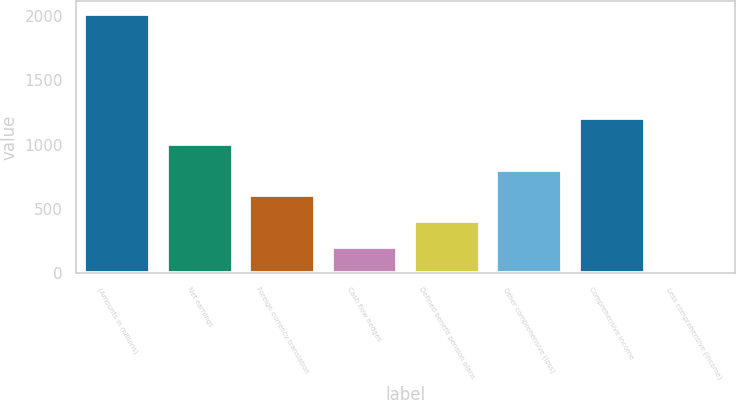Convert chart to OTSL. <chart><loc_0><loc_0><loc_500><loc_500><bar_chart><fcel>(Amounts in millions)<fcel>Net earnings<fcel>Foreign currency translation<fcel>Cash flow hedges<fcel>Defined benefit pension plans<fcel>Other comprehensive (loss)<fcel>Comprehensive income<fcel>Less comprehensive (income)<nl><fcel>2017<fcel>1008.55<fcel>605.17<fcel>201.79<fcel>403.48<fcel>806.86<fcel>1210.24<fcel>0.1<nl></chart> 